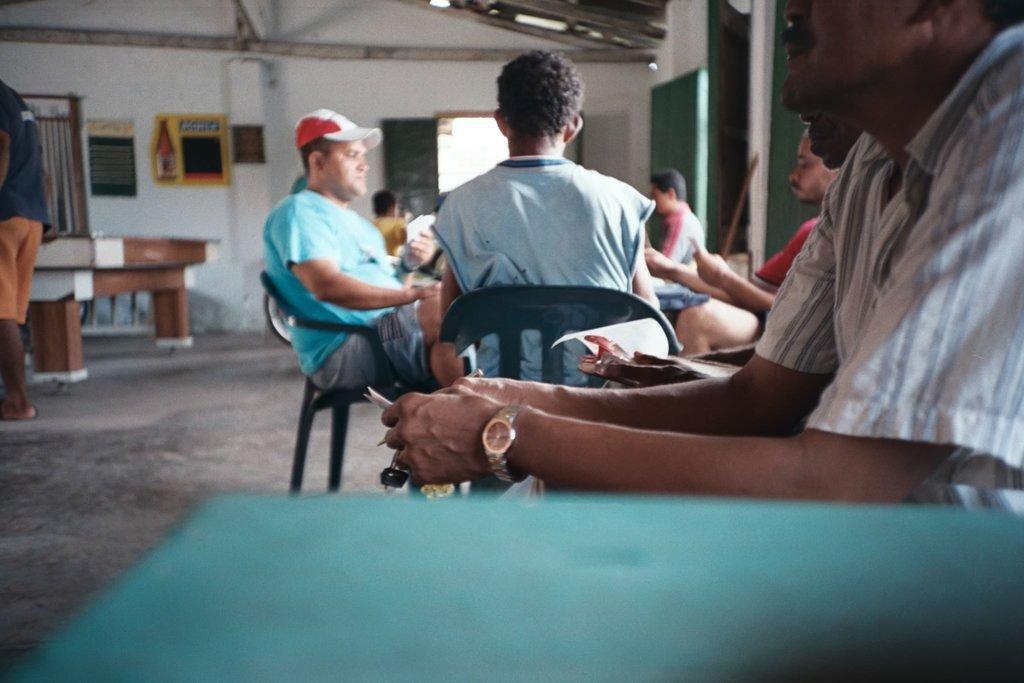How would you summarize this image in a sentence or two? In this image there are group of people sitting in chair near the table , and the back ground there is a frame attached to wall , another person standing , table, window, door. 